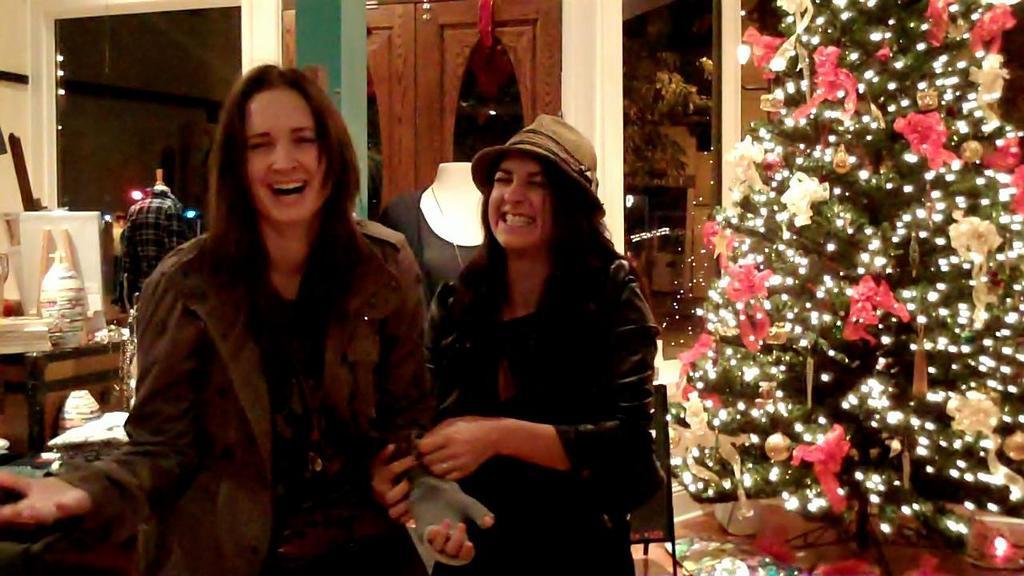Could you give a brief overview of what you see in this image? In this image there are two women in the middle of the room who are laughing. Beside them there is a tree which has lights on it. At the background there are mannequins,board,flower pot and a table. In the middle at the back side there is a door. 